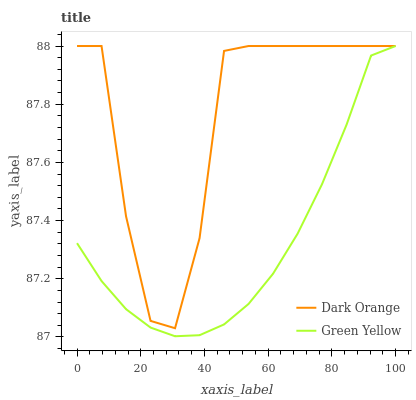Does Green Yellow have the minimum area under the curve?
Answer yes or no. Yes. Does Dark Orange have the maximum area under the curve?
Answer yes or no. Yes. Does Green Yellow have the maximum area under the curve?
Answer yes or no. No. Is Green Yellow the smoothest?
Answer yes or no. Yes. Is Dark Orange the roughest?
Answer yes or no. Yes. Is Green Yellow the roughest?
Answer yes or no. No. Does Green Yellow have the lowest value?
Answer yes or no. Yes. Does Green Yellow have the highest value?
Answer yes or no. Yes. Does Dark Orange intersect Green Yellow?
Answer yes or no. Yes. Is Dark Orange less than Green Yellow?
Answer yes or no. No. Is Dark Orange greater than Green Yellow?
Answer yes or no. No. 